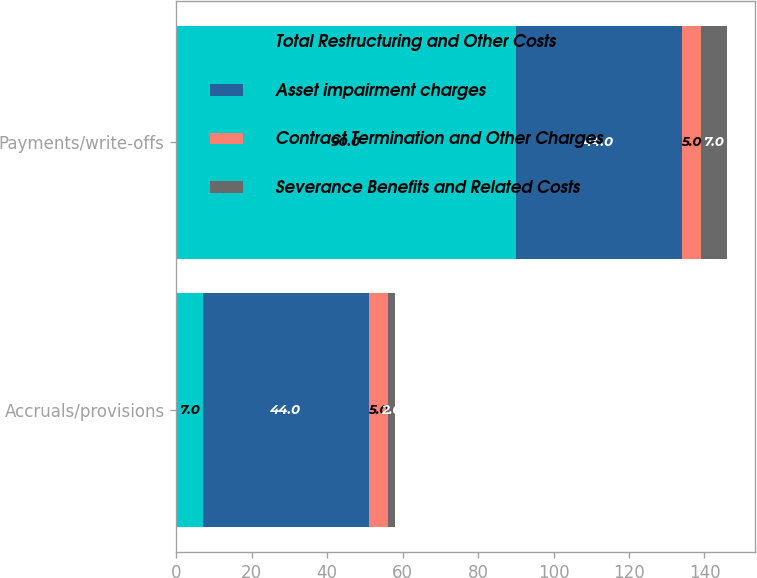<chart> <loc_0><loc_0><loc_500><loc_500><stacked_bar_chart><ecel><fcel>Accruals/provisions<fcel>Payments/write-offs<nl><fcel>Total Restructuring and Other Costs<fcel>7<fcel>90<nl><fcel>Asset impairment charges<fcel>44<fcel>44<nl><fcel>Contract Termination and Other Charges<fcel>5<fcel>5<nl><fcel>Severance Benefits and Related Costs<fcel>2<fcel>7<nl></chart> 